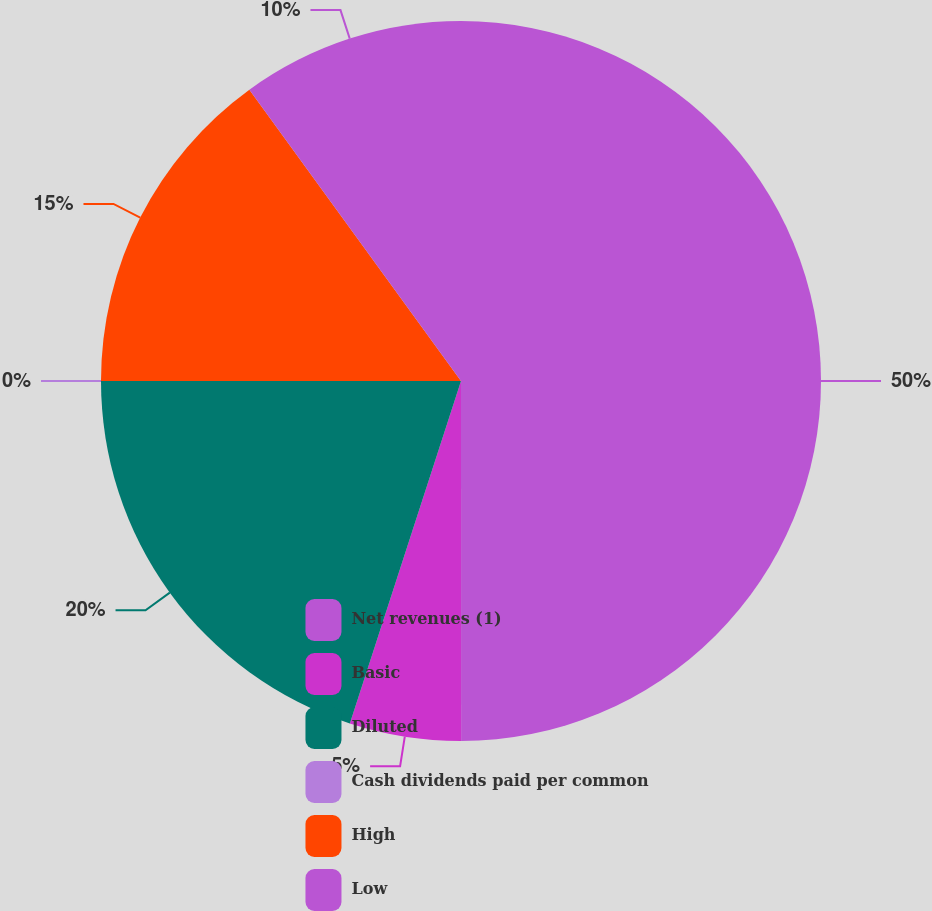Convert chart to OTSL. <chart><loc_0><loc_0><loc_500><loc_500><pie_chart><fcel>Net revenues (1)<fcel>Basic<fcel>Diluted<fcel>Cash dividends paid per common<fcel>High<fcel>Low<nl><fcel>49.99%<fcel>5.0%<fcel>20.0%<fcel>0.0%<fcel>15.0%<fcel>10.0%<nl></chart> 